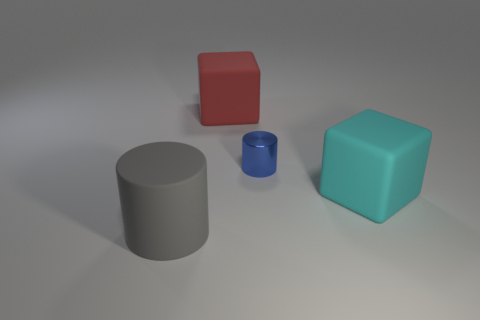Add 2 large cylinders. How many objects exist? 6 Subtract all red cubes. How many cubes are left? 1 Subtract 1 blue cylinders. How many objects are left? 3 Subtract 1 blocks. How many blocks are left? 1 Subtract all brown cylinders. Subtract all green balls. How many cylinders are left? 2 Subtract all blue spheres. How many gray cylinders are left? 1 Subtract all big purple matte objects. Subtract all gray matte cylinders. How many objects are left? 3 Add 1 big gray cylinders. How many big gray cylinders are left? 2 Add 4 large brown cubes. How many large brown cubes exist? 4 